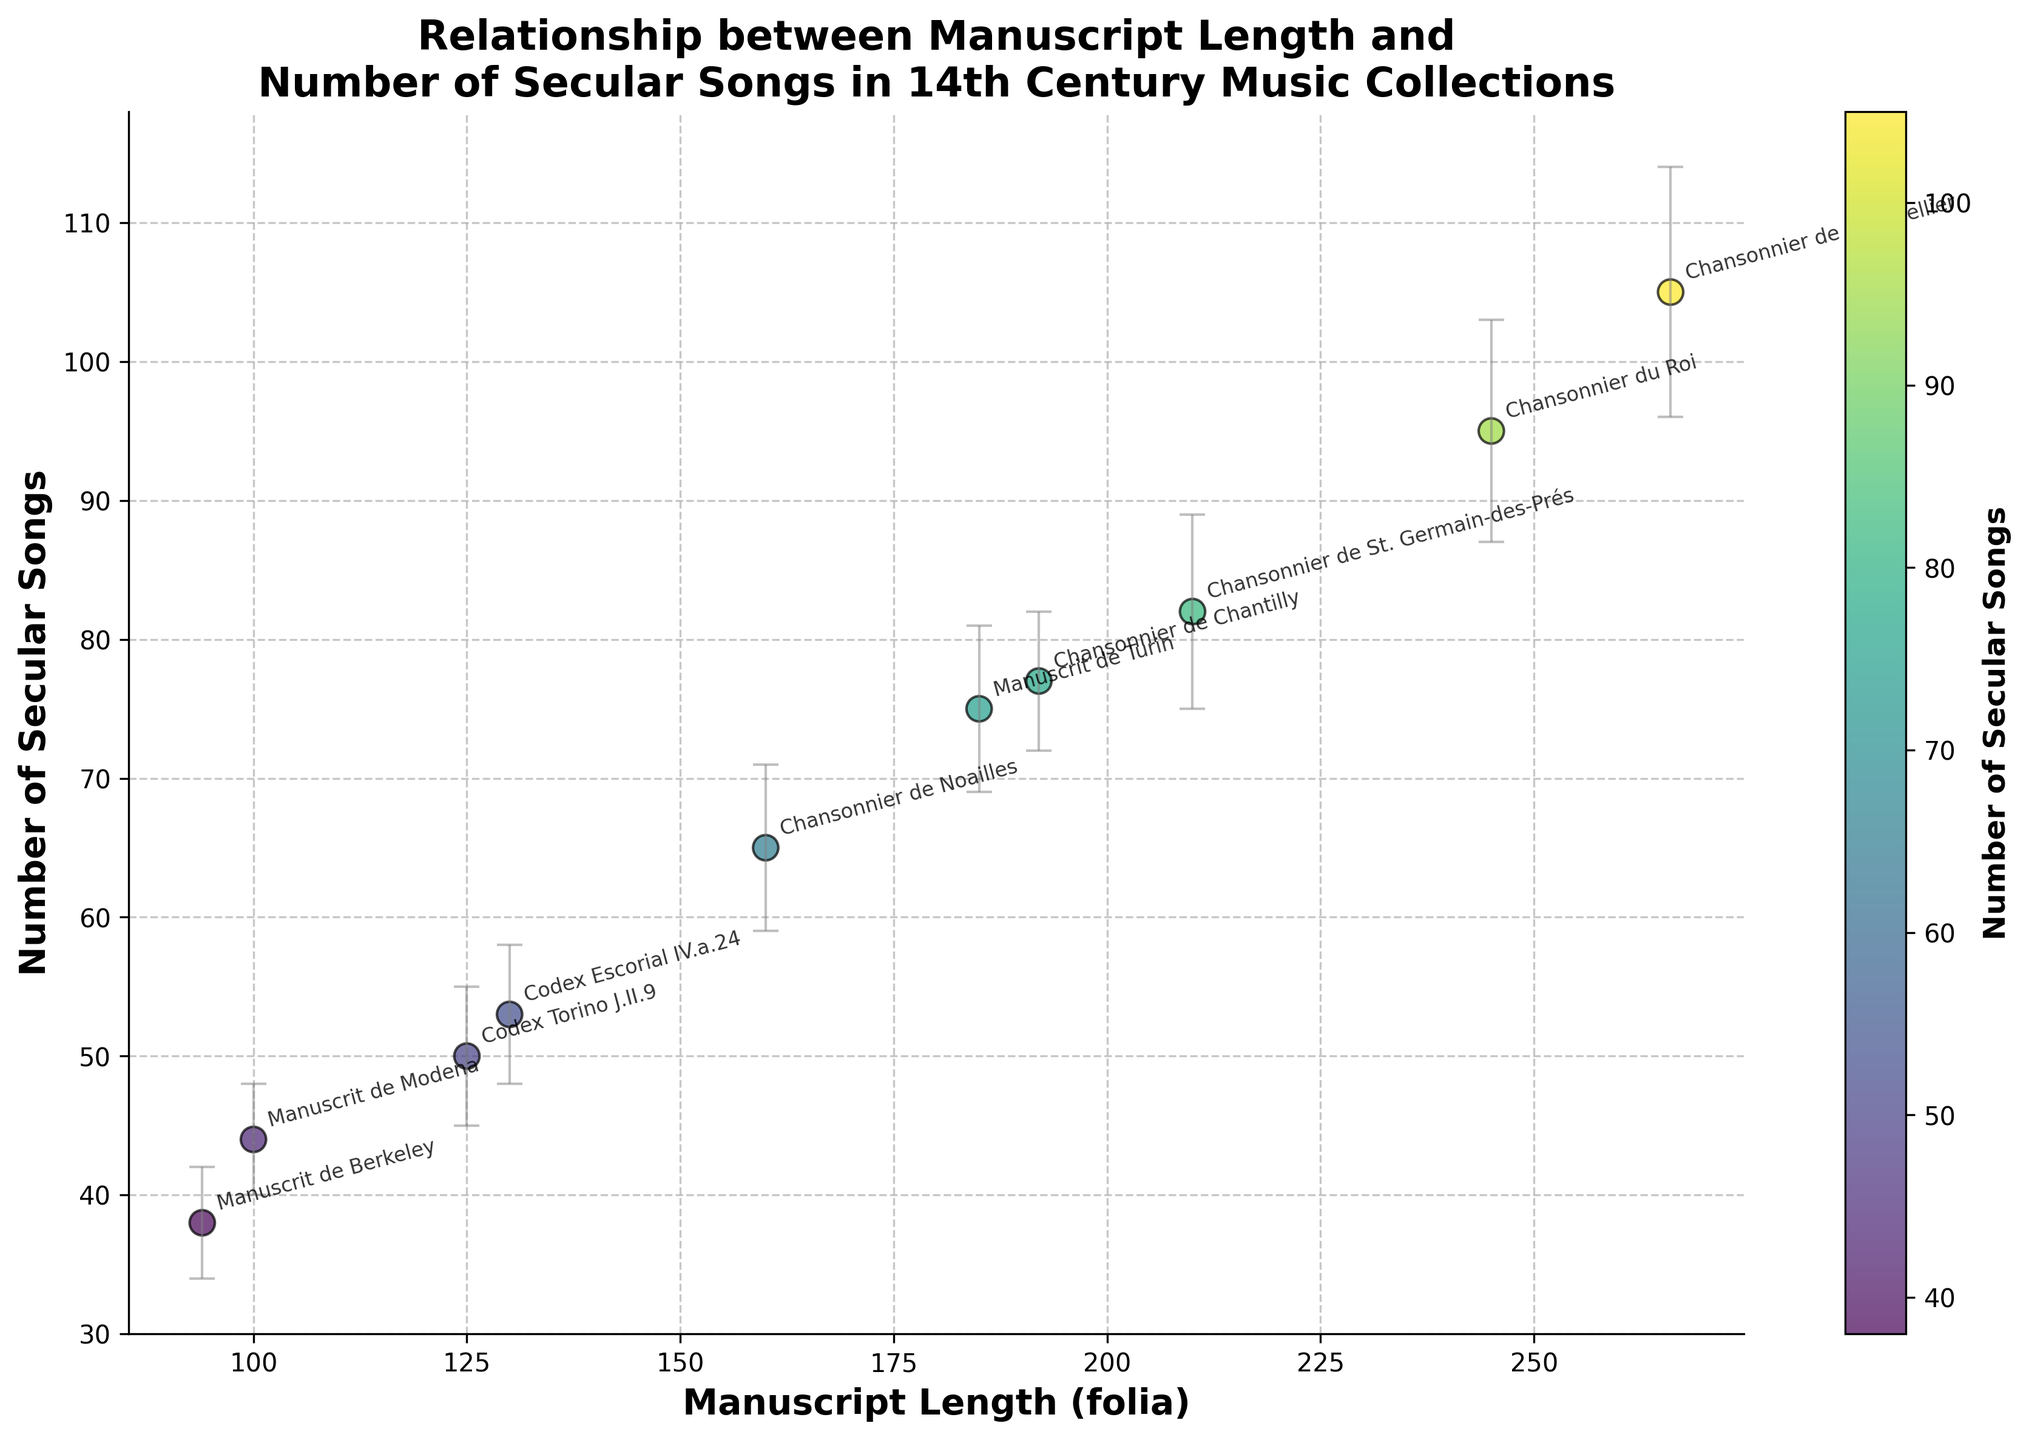What is the title of the figure? The title is usually found at the top of the figure. In this case, it is a bolded text.
Answer: Relationship between Manuscript Length and Number of Secular Songs in 14th Century Music Collections Which manuscript has the smallest number of secular songs? Locate the data point with the smallest value along the y-axis, which represents the number of secular songs. This point is annotated with the manuscript name.
Answer: Manuscrit de Berkeley How many manuscripts have more than 50 secular songs? Count the data points above the y-axis value of 50.
Answer: 6 Which manuscript has the largest length in folia, and how many secular songs does it contain? Identify the data point with the highest value along the x-axis (length in folia). The manuscript name will be annotated near this point. Then, look at the corresponding y-axis value for the number of secular songs.
Answer: Chansonnier de Montpellier, 105 What is the error range for the Chansonnier du Roi manuscript? Find the data point annotated with "Chansonnier du Roi" and check the error bars extending from this point. The error range is the distance from the top to the bottom of the error bars.
Answer: 8 What is the average number of secular songs for all manuscripts in the figure? Add up the number of secular songs for all manuscripts and divide by the total number of manuscripts (9). (77 + 95 + 65 + 44 + 82 + 50 + 105 + 38 + 75 + 53) / 10 = 68.4
Answer: 68.4 Which manuscript has the largest error in the number of secular songs? Identify the data point with the longest error bars. This point is annotated with the manuscript name.
Answer: Chansonnier de Montpellier Is there a positive relationship between manuscript length and the number of secular songs? Look for a visible trend in the scatter plot. A positive relationship means that as the x-axis (manuscript length) increases, the y-axis (number of secular songs) also increases.
Answer: Yes What's the difference in the number of secular songs between Chansonnier de Montpellier and Codex Torino J.II.9? Locate the points for Chansonnier de Montpellier and Codex Torino J.II.9. Subtract the y-value (number of secular songs) of Codex Torino J.II.9 from that of Chansonnier de Montpellier. 105 - 50 = 55
Answer: 55 